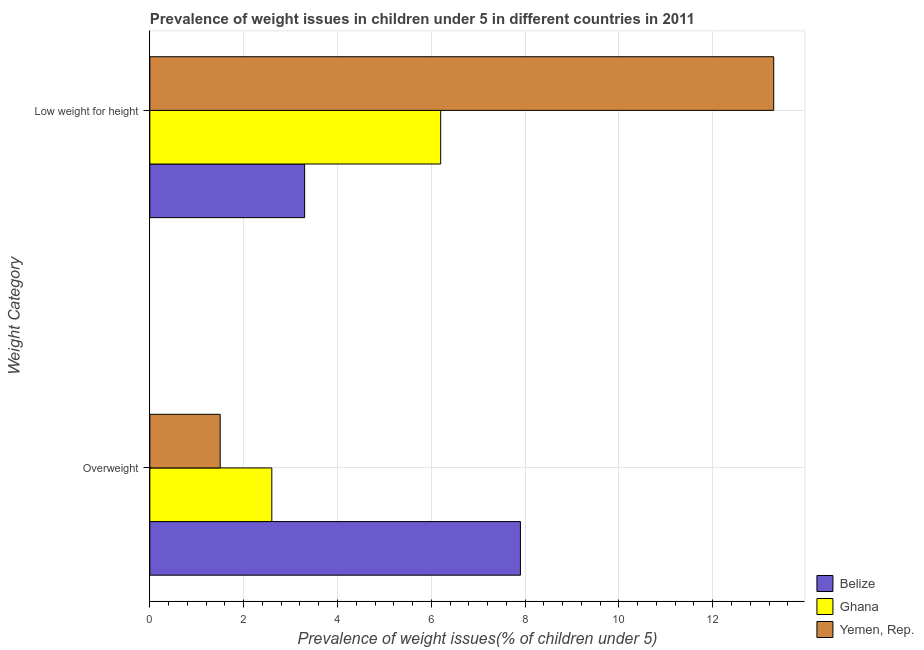Are the number of bars on each tick of the Y-axis equal?
Keep it short and to the point. Yes. What is the label of the 2nd group of bars from the top?
Your answer should be very brief. Overweight. What is the percentage of overweight children in Ghana?
Keep it short and to the point. 2.6. Across all countries, what is the maximum percentage of underweight children?
Offer a terse response. 13.3. Across all countries, what is the minimum percentage of underweight children?
Your answer should be compact. 3.3. In which country was the percentage of underweight children maximum?
Provide a short and direct response. Yemen, Rep. In which country was the percentage of underweight children minimum?
Your response must be concise. Belize. What is the total percentage of underweight children in the graph?
Offer a very short reply. 22.8. What is the difference between the percentage of underweight children in Belize and that in Yemen, Rep.?
Your answer should be compact. -10. What is the difference between the percentage of underweight children in Ghana and the percentage of overweight children in Yemen, Rep.?
Your response must be concise. 4.7. What is the average percentage of underweight children per country?
Your answer should be compact. 7.6. What is the difference between the percentage of underweight children and percentage of overweight children in Belize?
Keep it short and to the point. -4.6. In how many countries, is the percentage of overweight children greater than 0.8 %?
Ensure brevity in your answer.  3. What is the ratio of the percentage of underweight children in Ghana to that in Belize?
Offer a terse response. 1.88. Is the percentage of overweight children in Ghana less than that in Yemen, Rep.?
Ensure brevity in your answer.  No. What does the 2nd bar from the top in Low weight for height represents?
Provide a short and direct response. Ghana. What does the 2nd bar from the bottom in Overweight represents?
Make the answer very short. Ghana. How many bars are there?
Your answer should be very brief. 6. Are all the bars in the graph horizontal?
Offer a terse response. Yes. What is the difference between two consecutive major ticks on the X-axis?
Keep it short and to the point. 2. Does the graph contain grids?
Your answer should be compact. Yes. Where does the legend appear in the graph?
Your answer should be compact. Bottom right. How many legend labels are there?
Provide a succinct answer. 3. What is the title of the graph?
Make the answer very short. Prevalence of weight issues in children under 5 in different countries in 2011. Does "Solomon Islands" appear as one of the legend labels in the graph?
Provide a succinct answer. No. What is the label or title of the X-axis?
Offer a terse response. Prevalence of weight issues(% of children under 5). What is the label or title of the Y-axis?
Ensure brevity in your answer.  Weight Category. What is the Prevalence of weight issues(% of children under 5) in Belize in Overweight?
Ensure brevity in your answer.  7.9. What is the Prevalence of weight issues(% of children under 5) of Ghana in Overweight?
Your answer should be very brief. 2.6. What is the Prevalence of weight issues(% of children under 5) of Yemen, Rep. in Overweight?
Make the answer very short. 1.5. What is the Prevalence of weight issues(% of children under 5) in Belize in Low weight for height?
Make the answer very short. 3.3. What is the Prevalence of weight issues(% of children under 5) in Ghana in Low weight for height?
Offer a terse response. 6.2. What is the Prevalence of weight issues(% of children under 5) of Yemen, Rep. in Low weight for height?
Offer a very short reply. 13.3. Across all Weight Category, what is the maximum Prevalence of weight issues(% of children under 5) of Belize?
Your response must be concise. 7.9. Across all Weight Category, what is the maximum Prevalence of weight issues(% of children under 5) of Ghana?
Offer a terse response. 6.2. Across all Weight Category, what is the maximum Prevalence of weight issues(% of children under 5) of Yemen, Rep.?
Provide a short and direct response. 13.3. Across all Weight Category, what is the minimum Prevalence of weight issues(% of children under 5) in Belize?
Offer a very short reply. 3.3. Across all Weight Category, what is the minimum Prevalence of weight issues(% of children under 5) of Ghana?
Provide a short and direct response. 2.6. What is the total Prevalence of weight issues(% of children under 5) of Belize in the graph?
Keep it short and to the point. 11.2. What is the total Prevalence of weight issues(% of children under 5) in Ghana in the graph?
Ensure brevity in your answer.  8.8. What is the difference between the Prevalence of weight issues(% of children under 5) of Belize in Overweight and that in Low weight for height?
Your response must be concise. 4.6. What is the difference between the Prevalence of weight issues(% of children under 5) in Yemen, Rep. in Overweight and that in Low weight for height?
Make the answer very short. -11.8. What is the difference between the Prevalence of weight issues(% of children under 5) of Belize in Overweight and the Prevalence of weight issues(% of children under 5) of Ghana in Low weight for height?
Ensure brevity in your answer.  1.7. What is the difference between the Prevalence of weight issues(% of children under 5) of Belize in Overweight and the Prevalence of weight issues(% of children under 5) of Yemen, Rep. in Low weight for height?
Your answer should be very brief. -5.4. What is the average Prevalence of weight issues(% of children under 5) in Belize per Weight Category?
Make the answer very short. 5.6. What is the difference between the Prevalence of weight issues(% of children under 5) in Belize and Prevalence of weight issues(% of children under 5) in Ghana in Overweight?
Provide a succinct answer. 5.3. What is the difference between the Prevalence of weight issues(% of children under 5) of Belize and Prevalence of weight issues(% of children under 5) of Yemen, Rep. in Low weight for height?
Provide a succinct answer. -10. What is the difference between the Prevalence of weight issues(% of children under 5) in Ghana and Prevalence of weight issues(% of children under 5) in Yemen, Rep. in Low weight for height?
Your answer should be compact. -7.1. What is the ratio of the Prevalence of weight issues(% of children under 5) in Belize in Overweight to that in Low weight for height?
Keep it short and to the point. 2.39. What is the ratio of the Prevalence of weight issues(% of children under 5) of Ghana in Overweight to that in Low weight for height?
Keep it short and to the point. 0.42. What is the ratio of the Prevalence of weight issues(% of children under 5) in Yemen, Rep. in Overweight to that in Low weight for height?
Offer a very short reply. 0.11. What is the difference between the highest and the second highest Prevalence of weight issues(% of children under 5) in Belize?
Offer a very short reply. 4.6. What is the difference between the highest and the second highest Prevalence of weight issues(% of children under 5) in Ghana?
Give a very brief answer. 3.6. What is the difference between the highest and the second highest Prevalence of weight issues(% of children under 5) in Yemen, Rep.?
Give a very brief answer. 11.8. 